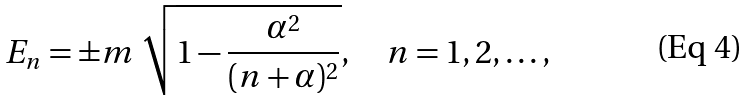<formula> <loc_0><loc_0><loc_500><loc_500>E _ { n } = \pm m \ \sqrt { 1 - \frac { \alpha ^ { 2 } } { ( n + \alpha ) ^ { 2 } } } , \quad n = 1 , 2 , \dots ,</formula> 